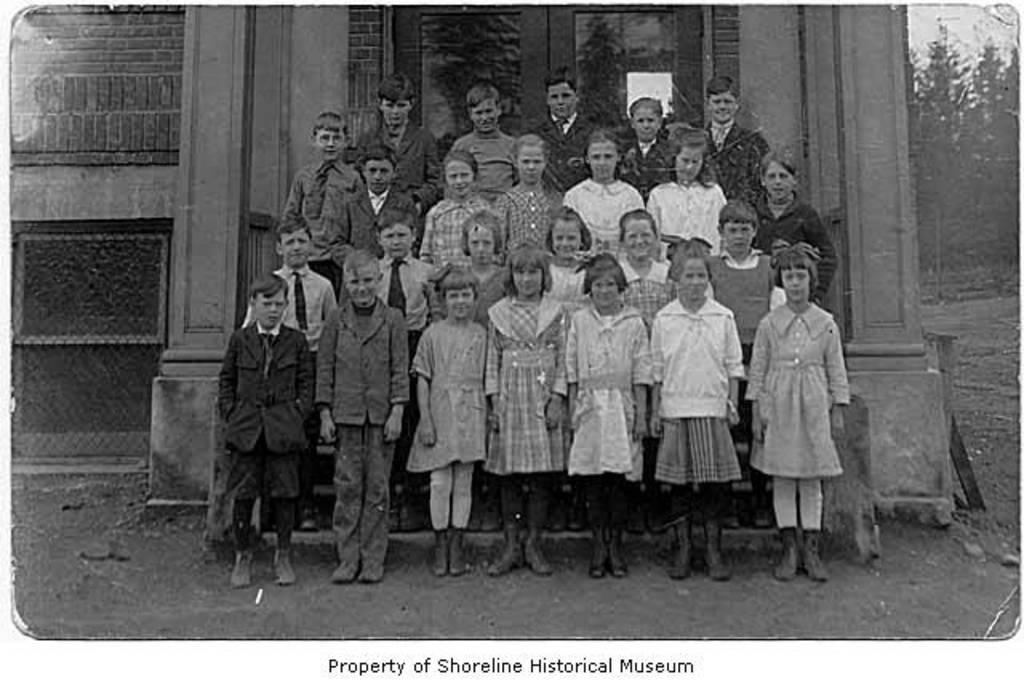Can you describe this image briefly? This is a black and white picture. Here we can see pillars, wall, door, ground, trees, and group of children. At the bottom of the image we can see something is written on it. 